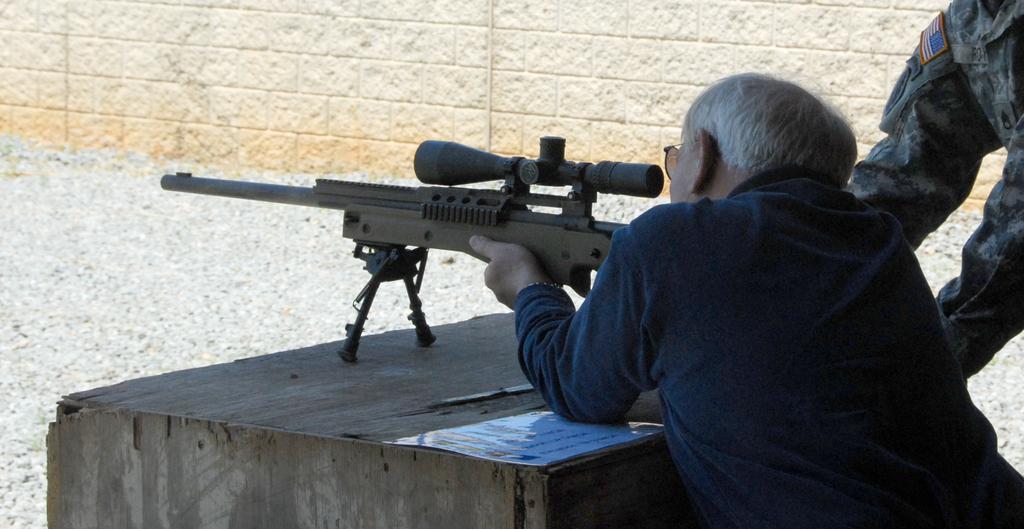Describe this image in one or two sentences. In this image we can see a man standing and looking through a sniper. In the background we can see walls and an another person. 